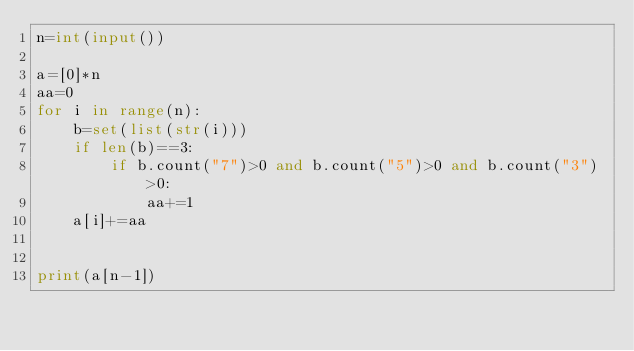Convert code to text. <code><loc_0><loc_0><loc_500><loc_500><_Python_>n=int(input())

a=[0]*n
aa=0
for i in range(n):
    b=set(list(str(i)))
    if len(b)==3:
        if b.count("7")>0 and b.count("5")>0 and b.count("3")>0:
            aa+=1
    a[i]+=aa


print(a[n-1])</code> 